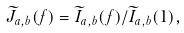<formula> <loc_0><loc_0><loc_500><loc_500>\widetilde { J } _ { a , b } ( f ) = \widetilde { I } _ { a , b } ( f ) / \widetilde { I } _ { a , b } ( 1 ) ,</formula> 